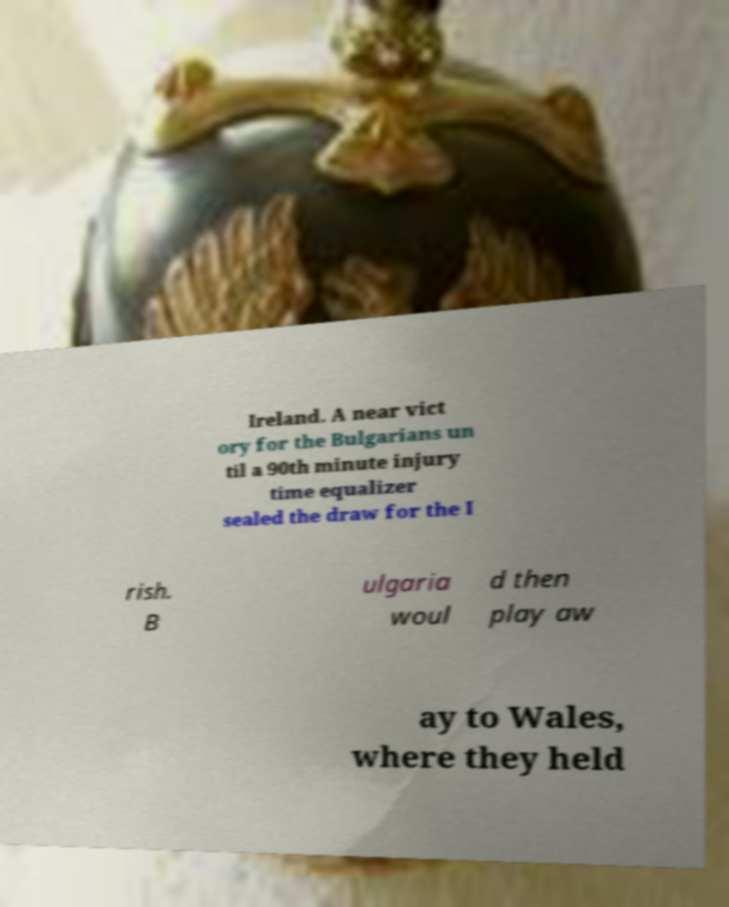For documentation purposes, I need the text within this image transcribed. Could you provide that? Ireland. A near vict ory for the Bulgarians un til a 90th minute injury time equalizer sealed the draw for the I rish. B ulgaria woul d then play aw ay to Wales, where they held 